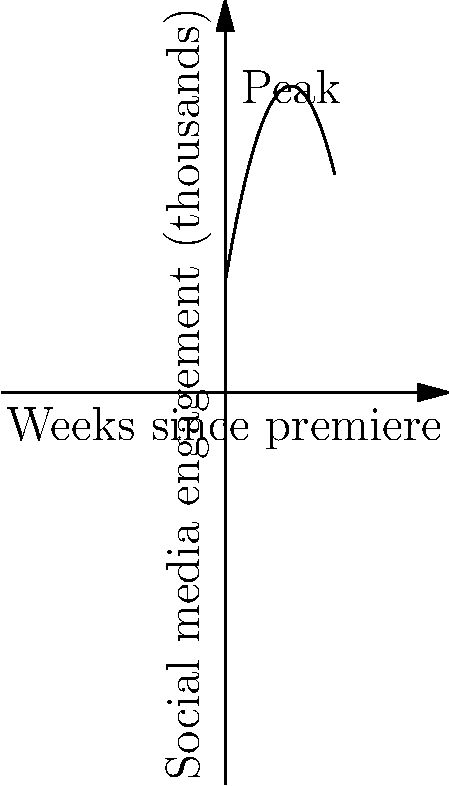The quadratic function $f(x) = -0.5x^2 + 6x + 10$ represents the social media engagement (in thousands) for a new show over time, where $x$ is the number of weeks since the premiere. At how many weeks after the premiere does the show reach its peak engagement? To find the peak of a quadratic function, we need to follow these steps:

1) The general form of a quadratic function is $f(x) = ax^2 + bx + c$, where $a$, $b$, and $c$ are constants and $a \neq 0$.

2) In this case, $a = -0.5$, $b = 6$, and $c = 10$.

3) The x-coordinate of the vertex (peak) of a parabola can be found using the formula: $x = -\frac{b}{2a}$

4) Substituting our values:
   $x = -\frac{6}{2(-0.5)} = -\frac{6}{-1} = 6$

5) Therefore, the peak occurs 6 weeks after the premiere.

We can verify this by looking at the graph, where we can see the peak is indeed at $x = 6$.
Answer: 6 weeks 